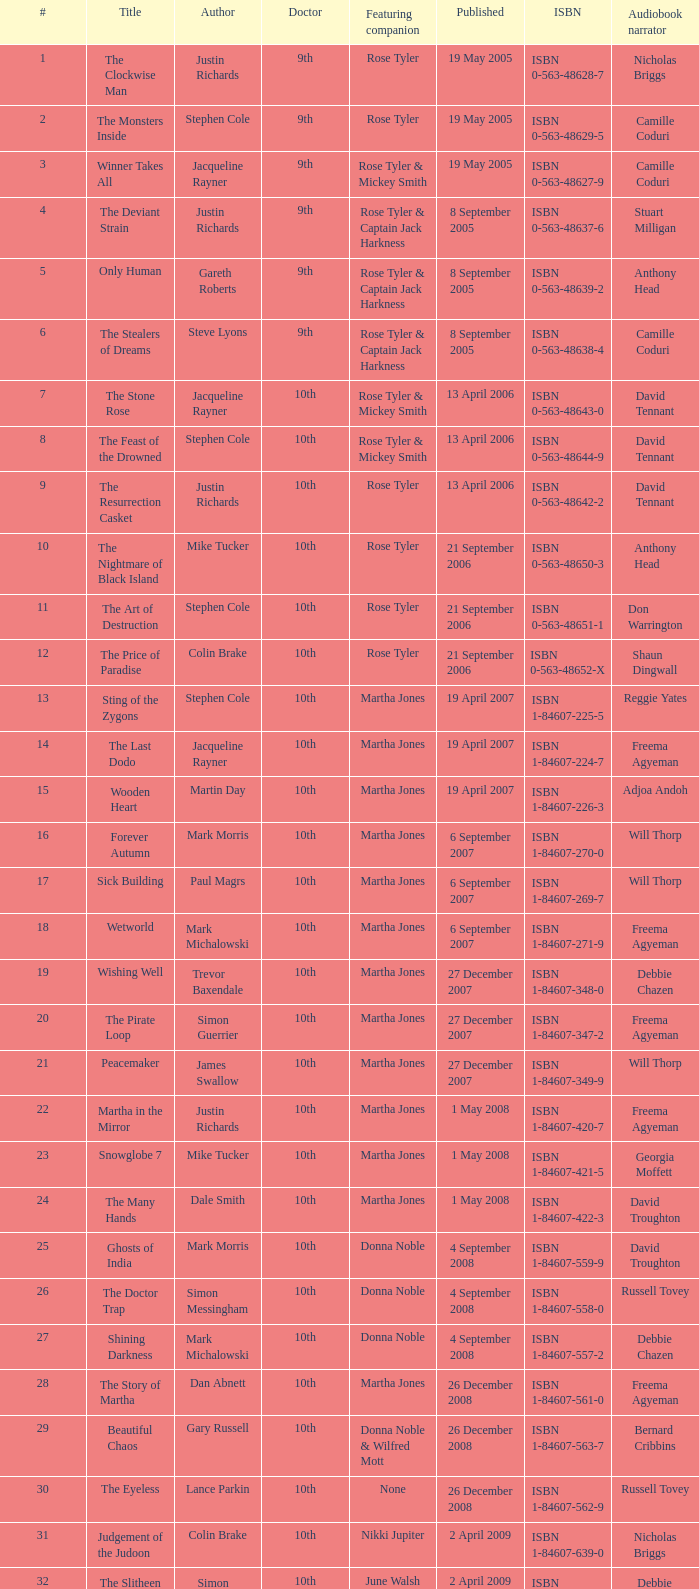What is the title of book number 8? The Feast of the Drowned. 